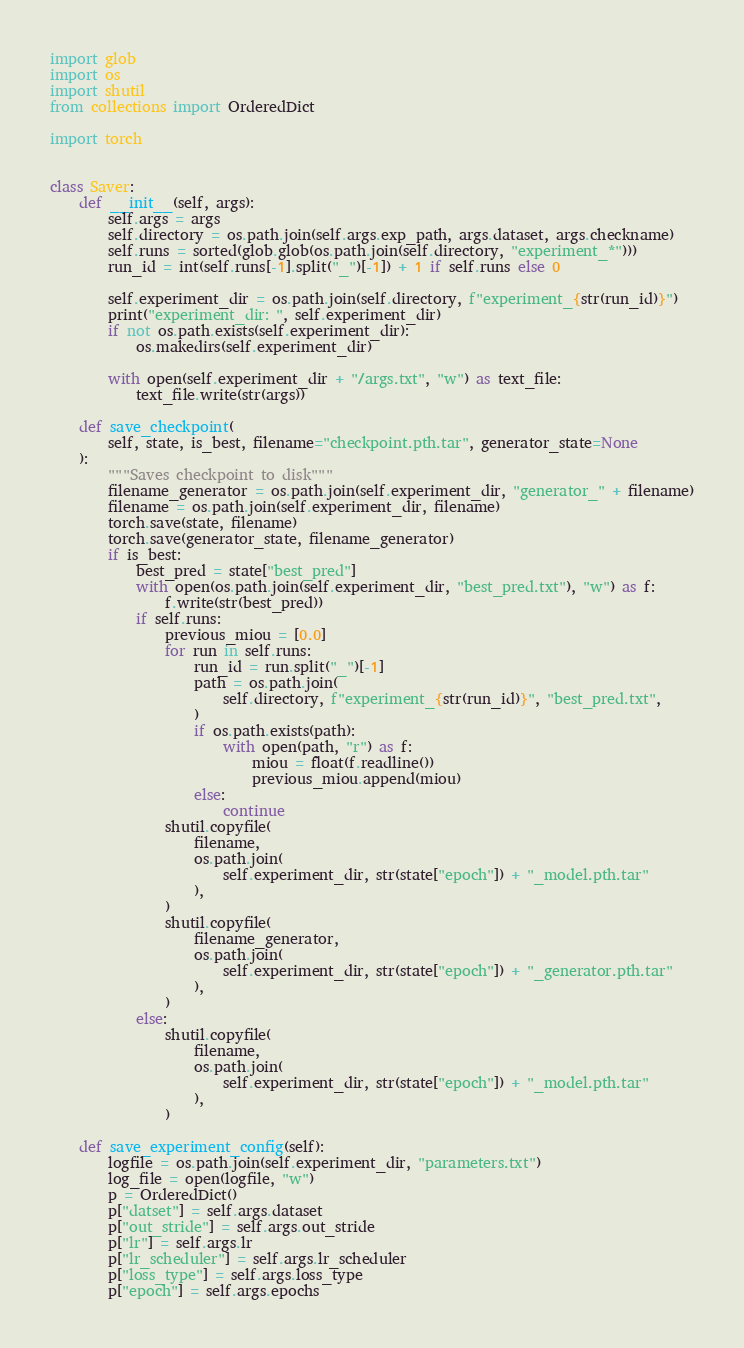<code> <loc_0><loc_0><loc_500><loc_500><_Python_>import glob
import os
import shutil
from collections import OrderedDict

import torch


class Saver:
    def __init__(self, args):
        self.args = args
        self.directory = os.path.join(self.args.exp_path, args.dataset, args.checkname)
        self.runs = sorted(glob.glob(os.path.join(self.directory, "experiment_*")))
        run_id = int(self.runs[-1].split("_")[-1]) + 1 if self.runs else 0

        self.experiment_dir = os.path.join(self.directory, f"experiment_{str(run_id)}")
        print("experiment_dir: ", self.experiment_dir)
        if not os.path.exists(self.experiment_dir):
            os.makedirs(self.experiment_dir)

        with open(self.experiment_dir + "/args.txt", "w") as text_file:
            text_file.write(str(args))

    def save_checkpoint(
        self, state, is_best, filename="checkpoint.pth.tar", generator_state=None
    ):
        """Saves checkpoint to disk"""
        filename_generator = os.path.join(self.experiment_dir, "generator_" + filename)
        filename = os.path.join(self.experiment_dir, filename)
        torch.save(state, filename)
        torch.save(generator_state, filename_generator)
        if is_best:
            best_pred = state["best_pred"]
            with open(os.path.join(self.experiment_dir, "best_pred.txt"), "w") as f:
                f.write(str(best_pred))
            if self.runs:
                previous_miou = [0.0]
                for run in self.runs:
                    run_id = run.split("_")[-1]
                    path = os.path.join(
                        self.directory, f"experiment_{str(run_id)}", "best_pred.txt",
                    )
                    if os.path.exists(path):
                        with open(path, "r") as f:
                            miou = float(f.readline())
                            previous_miou.append(miou)
                    else:
                        continue
                shutil.copyfile(
                    filename,
                    os.path.join(
                        self.experiment_dir, str(state["epoch"]) + "_model.pth.tar"
                    ),
                )
                shutil.copyfile(
                    filename_generator,
                    os.path.join(
                        self.experiment_dir, str(state["epoch"]) + "_generator.pth.tar"
                    ),
                )
            else:
                shutil.copyfile(
                    filename,
                    os.path.join(
                        self.experiment_dir, str(state["epoch"]) + "_model.pth.tar"
                    ),
                )

    def save_experiment_config(self):
        logfile = os.path.join(self.experiment_dir, "parameters.txt")
        log_file = open(logfile, "w")
        p = OrderedDict()
        p["datset"] = self.args.dataset
        p["out_stride"] = self.args.out_stride
        p["lr"] = self.args.lr
        p["lr_scheduler"] = self.args.lr_scheduler
        p["loss_type"] = self.args.loss_type
        p["epoch"] = self.args.epochs</code> 